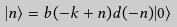<formula> <loc_0><loc_0><loc_500><loc_500>| n \rangle = b ( - k + n ) d ( - n ) | 0 \rangle</formula> 